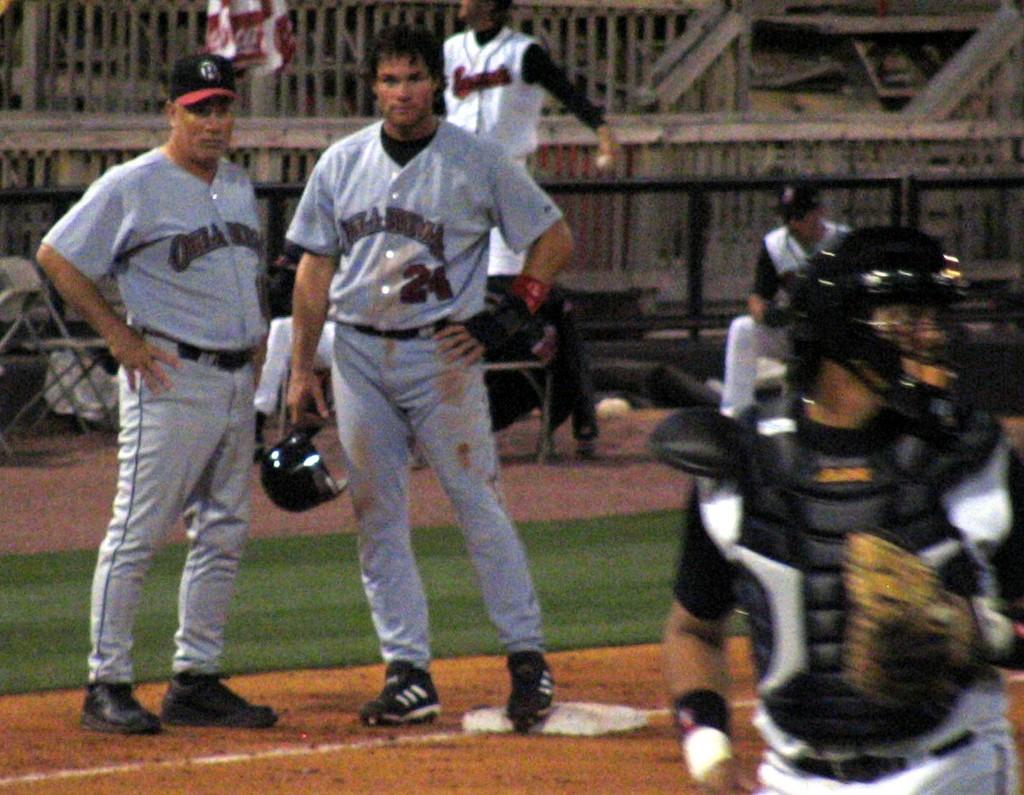What number is on dudes pants?
Make the answer very short. Unanswerable. 